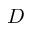<formula> <loc_0><loc_0><loc_500><loc_500>D</formula> 